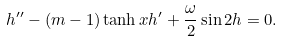<formula> <loc_0><loc_0><loc_500><loc_500>h ^ { \prime \prime } - ( m - 1 ) \tanh { x } h ^ { \prime } + \frac { \omega } { 2 } \sin { 2 h } = 0 .</formula> 